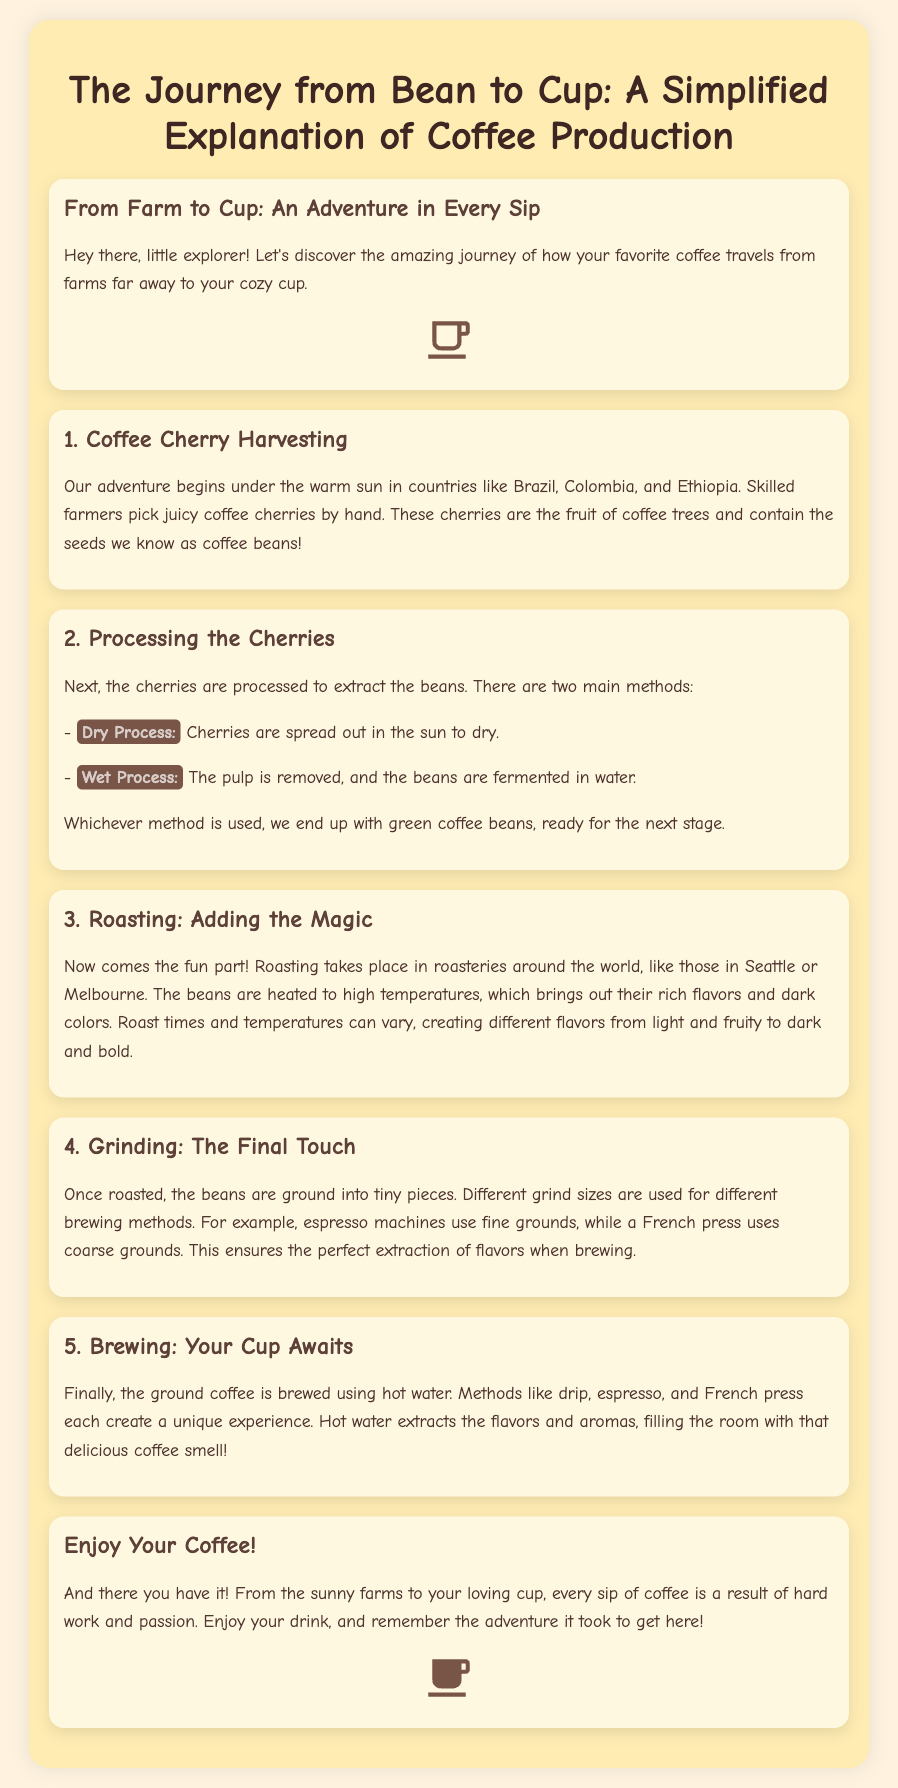What is the main theme of the document? The document explains the journey of coffee production, from the farm to the cup.
Answer: The journey of coffee production What is the first step in coffee production? The document mentions that the first step is harvesting coffee cherries.
Answer: Coffee Cherry Harvesting What are the two main methods of processing cherries? The document lists dry process and wet process as the two main methods.
Answer: Dry Process and Wet Process What is highlighted as the fun part of coffee production? The roasting stage is described as the fun part where flavors are developed.
Answer: Roasting What is one brewing method mentioned in the document? The document gives examples of brewing methods, naming drip coffee as one option.
Answer: Drip How many sections are there discussing different stages of coffee production? The document has five sections describing various stages of coffee production.
Answer: Five Where does the journey of coffee begin? The document states that the journey starts in countries like Brazil, Colombia, and Ethiopia.
Answer: Brazil, Colombia, and Ethiopia What does the final section encourage readers to do? The final section invites readers to enjoy their coffee and appreciate its journey.
Answer: Enjoy Your Coffee What type of coffee do espresso machines use? The document specifies that espresso machines use fine grounds for brewing.
Answer: Fine grounds 